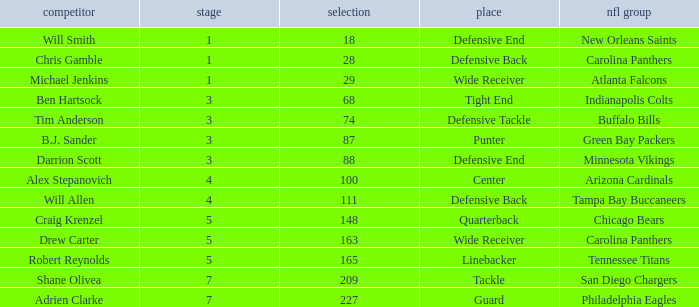What is the highest round number of a Pick after 209. 7.0. 